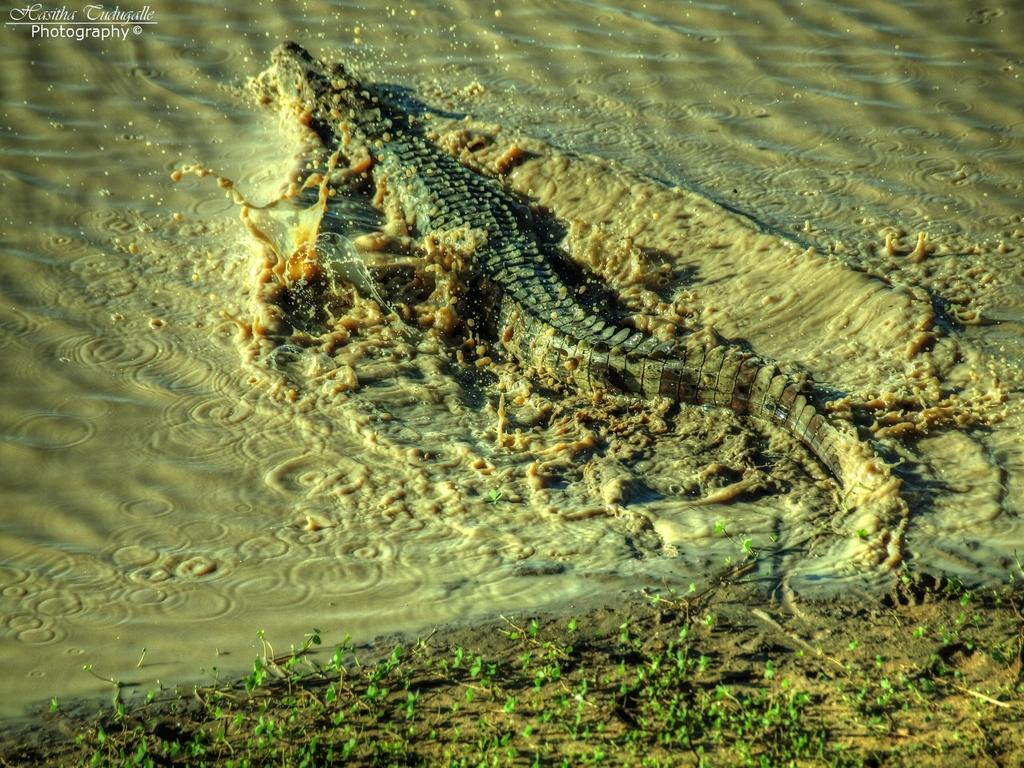What animal can be seen in the water in the image? There is a crocodile in the water in the image. What type of terrain is visible in the image? The ground with plants is visible in the image. Is there any additional information or markings on the image? Yes, there is a watermark in the top left corner of the picture. How many eyes does the ink have in the image? There is no ink present in the image, so it does not have any eyes. 